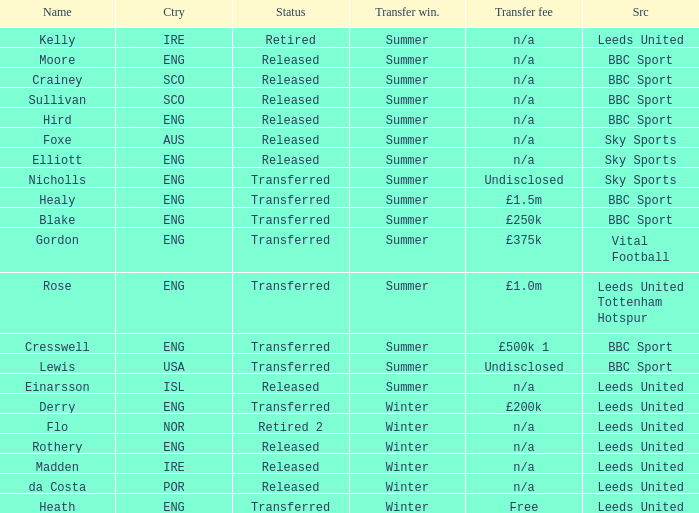What is the person's name that is from the country of SCO? Crainey, Sullivan. 